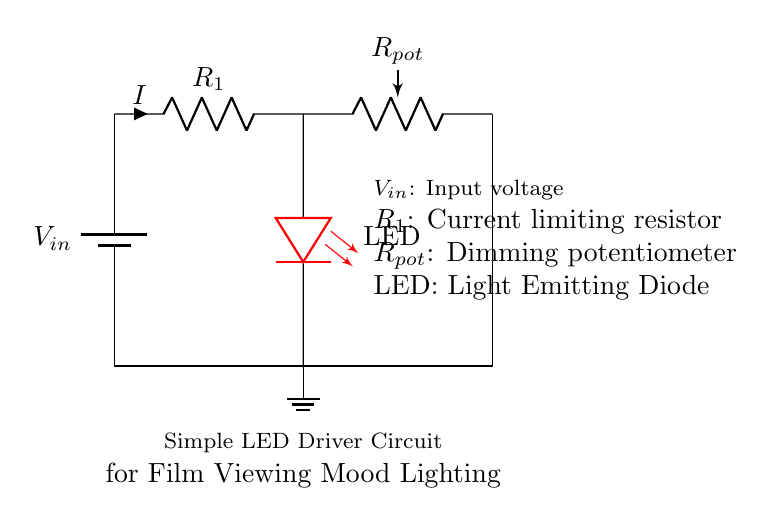What is the input voltage symbol in the circuit? The input voltage in the circuit is represented by the symbol \( V_{in} \) near the battery, indicating the source of power for the LED driver circuit.
Answer: \( V_{in} \) What type of component is labeled as LED? The component labeled as LED is a light-emitting diode, which is indicated by its specific symbol in the circuit diagram. It is also colored red, which further confirms its identity.
Answer: Light Emitting Diode What role does the resistor R1 play in the circuit? The resistor R1 serves as a current limiting resistor in the circuit, which is necessary to prevent excessive current flow through the LED that could damage it. The current's direction is indicated by the arrow showing it as flowing into the resistor.
Answer: Current limiting resistor How is dimming achieved in this LED driver circuit? Dimming in this circuit is achieved through the potentiometer labeled \( R_{pot} \). The position of the potentiometer can be adjusted to change its resistance, which in turn adjusts the amount of current flowing through the LED, allowing for varying brightness levels.
Answer: Through the potentiometer \( R_{pot} \) What happens when the potentiometer \( R_{pot} \) is turned to maximum resistance? When the potentiometer is turned to maximum resistance, the current flowing through the LED will decrease significantly, leading to dimmer lighting effects. As the resistance increases, less current can pass through, dimming the LED's brightness.
Answer: The LED dims What is the purpose of the ground connection in this circuit? The ground connection in the circuit provides a reference point for the voltage levels in the circuit and completes the electrical circuit path by connecting to the negative terminal of the power supply, allowing current to flow properly.
Answer: Reference point and circuit completion 